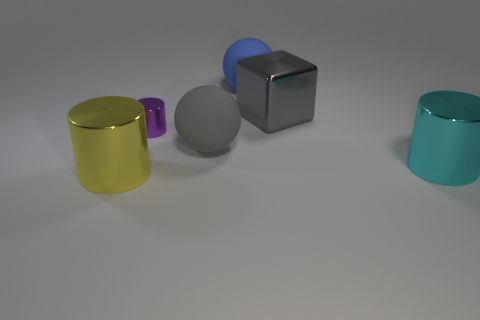Add 1 large yellow shiny blocks. How many objects exist? 7 Subtract all balls. How many objects are left? 4 Subtract all green metal cylinders. Subtract all big cyan objects. How many objects are left? 5 Add 4 large shiny cubes. How many large shiny cubes are left? 5 Add 2 gray matte objects. How many gray matte objects exist? 3 Subtract 0 brown cylinders. How many objects are left? 6 